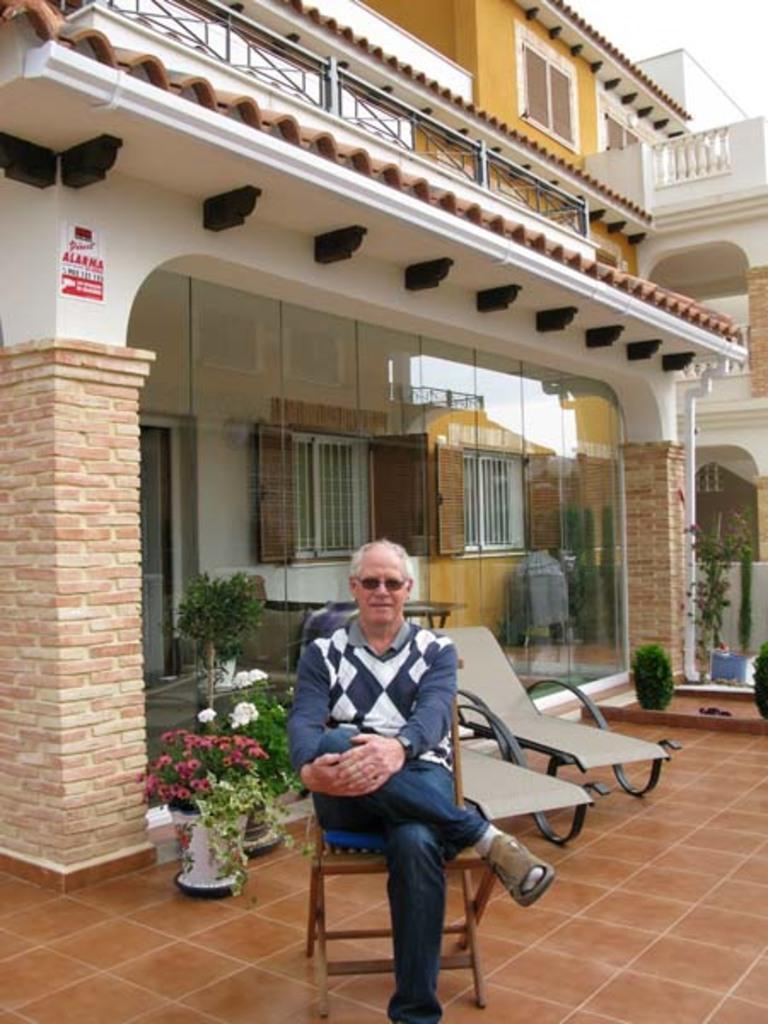In one or two sentences, can you explain what this image depicts? This image is taken outdoors. At the bottom of the image there is a floor. In the background there are two houses. There are a few plants in the pots. There is a poster on the wall. There are two pillars. In the middle of the image there are two resting chairs and a man is sitting on the chair. 